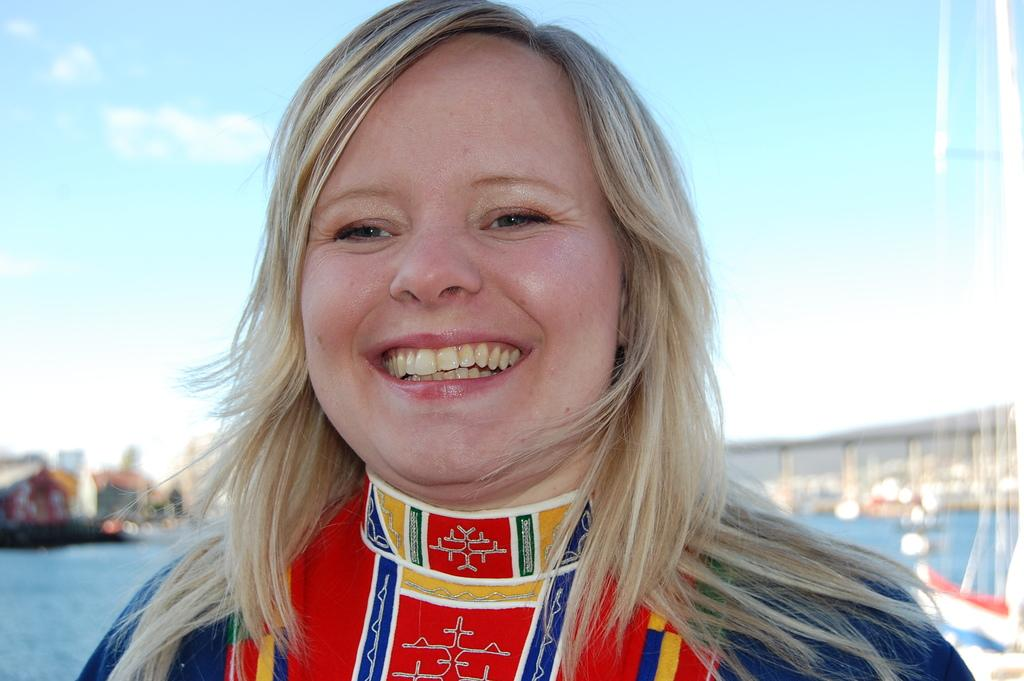Who is present in the image? There is a woman in the image. What expression does the woman have? The woman is smiling. Can you describe the background of the image? The background of the image is blurry, with water and the sky visible. How many chins does the woman have in the image? The number of chins cannot be determined from the image, as it only shows the woman's face from a distance and does not provide enough detail to count chins. 